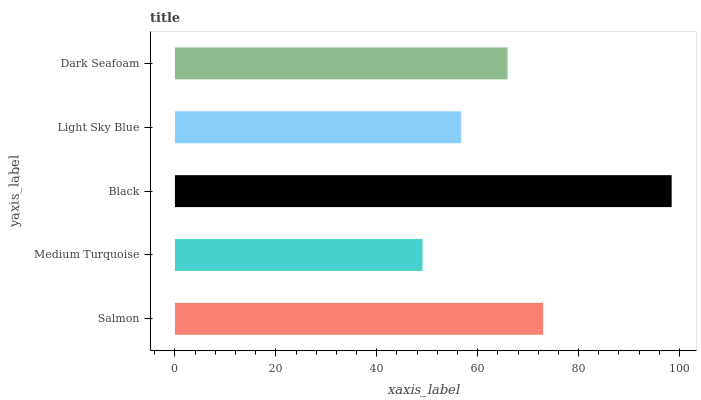Is Medium Turquoise the minimum?
Answer yes or no. Yes. Is Black the maximum?
Answer yes or no. Yes. Is Black the minimum?
Answer yes or no. No. Is Medium Turquoise the maximum?
Answer yes or no. No. Is Black greater than Medium Turquoise?
Answer yes or no. Yes. Is Medium Turquoise less than Black?
Answer yes or no. Yes. Is Medium Turquoise greater than Black?
Answer yes or no. No. Is Black less than Medium Turquoise?
Answer yes or no. No. Is Dark Seafoam the high median?
Answer yes or no. Yes. Is Dark Seafoam the low median?
Answer yes or no. Yes. Is Salmon the high median?
Answer yes or no. No. Is Salmon the low median?
Answer yes or no. No. 